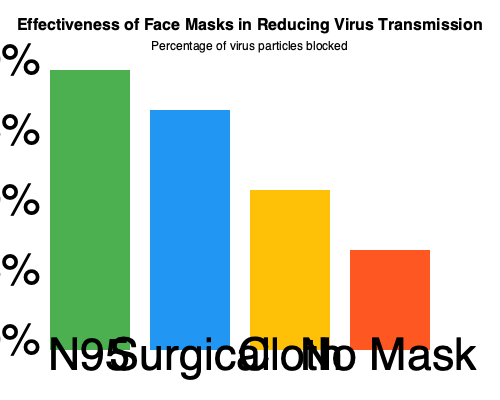As a talk show host discussing the latest developments in infectious diseases with a specialist, you're presented with this bar chart comparing the effectiveness of different types of face masks. Which type of face mask shows the highest effectiveness in reducing virus transmission, and approximately what percentage of virus particles does it block? To answer this question, we need to analyze the bar chart provided:

1. The chart shows four types of face coverings: N95, Surgical, Cloth, and No Mask.
2. The y-axis represents the percentage of virus particles blocked, ranging from 0% to 100%.
3. Each bar's height corresponds to the effectiveness of the mask type.

Let's examine each mask type:

1. N95 mask (leftmost bar):
   - The bar reaches almost to the top of the chart.
   - It appears to block approximately 90-95% of virus particles.

2. Surgical mask (second bar):
   - The bar is slightly shorter than the N95 bar.
   - It seems to block about 80-85% of virus particles.

3. Cloth mask (third bar):
   - The bar is noticeably shorter than surgical and N95 masks.
   - It appears to block roughly 50-55% of virus particles.

4. No mask (rightmost bar):
   - This bar is the shortest, as expected.
   - It shows minimal protection, blocking only about 20-25% of virus particles.

Comparing all four options, the N95 mask clearly shows the highest effectiveness in reducing virus transmission.
Answer: N95 mask, blocking approximately 95% of virus particles. 